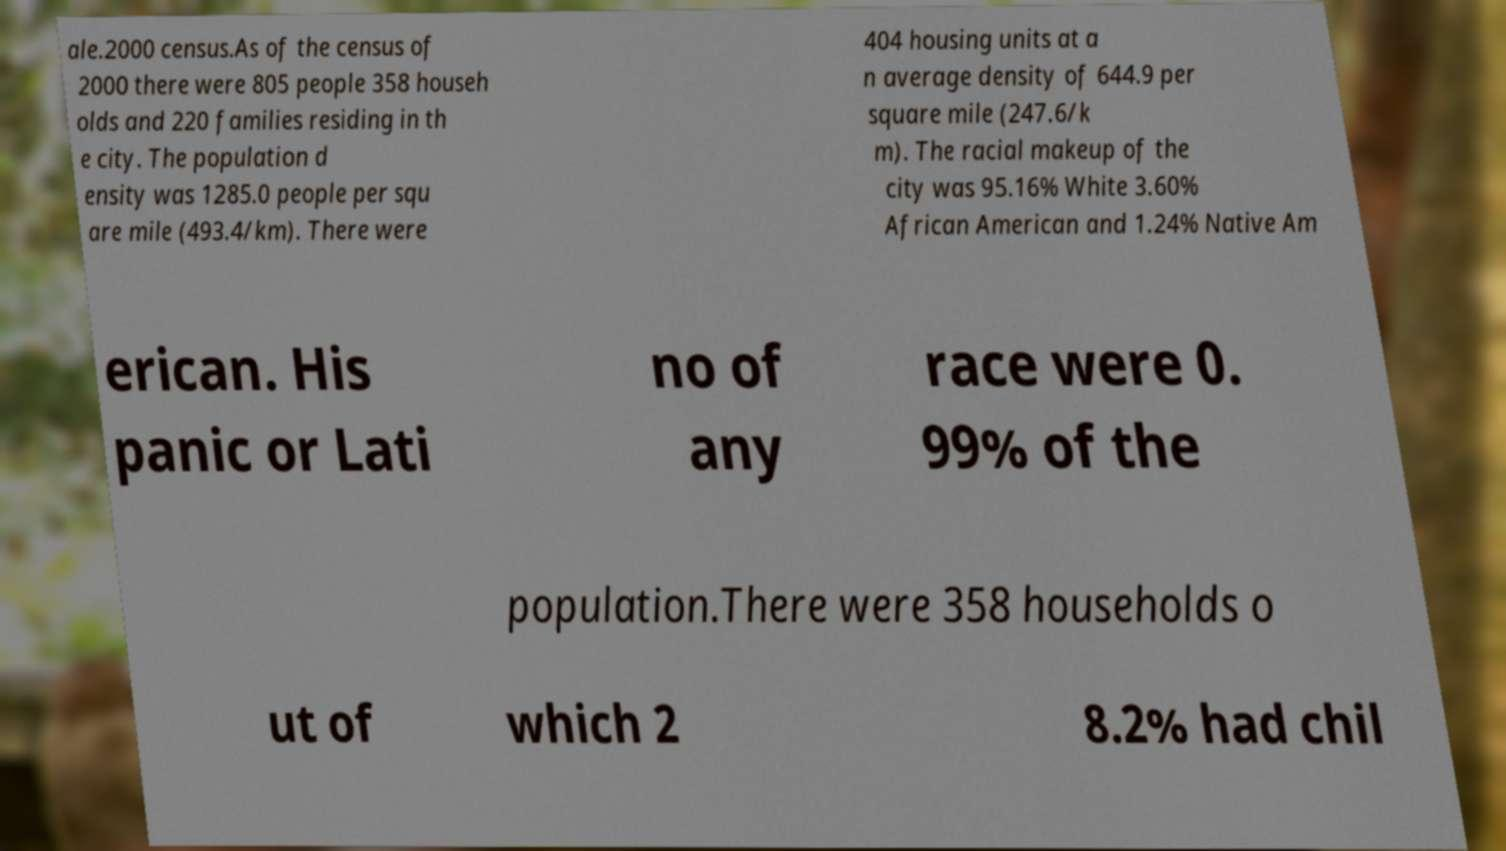There's text embedded in this image that I need extracted. Can you transcribe it verbatim? ale.2000 census.As of the census of 2000 there were 805 people 358 househ olds and 220 families residing in th e city. The population d ensity was 1285.0 people per squ are mile (493.4/km). There were 404 housing units at a n average density of 644.9 per square mile (247.6/k m). The racial makeup of the city was 95.16% White 3.60% African American and 1.24% Native Am erican. His panic or Lati no of any race were 0. 99% of the population.There were 358 households o ut of which 2 8.2% had chil 